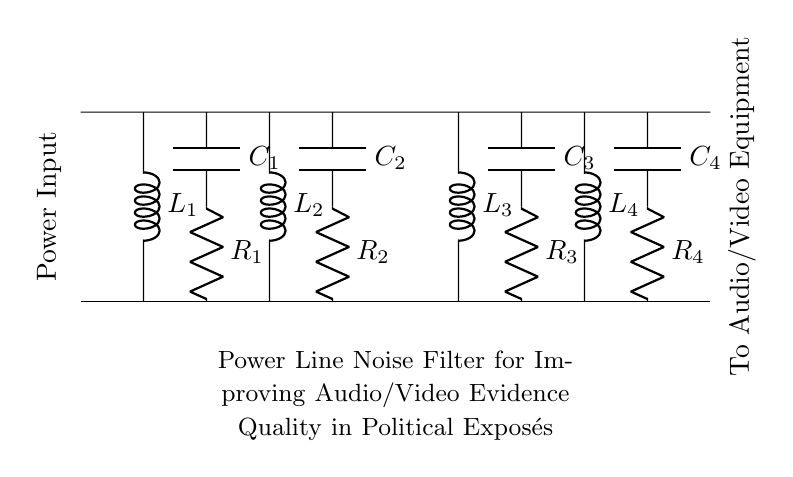What is the total number of inductors in the circuit? There are four inductors labeled L1, L2, L3, and L4 in the circuit diagram, which can be counted visually.
Answer: Four What type of components are R1, R2, R3, and R4? R1, R2, R3, and R4 are resistors. They can be identified by the 'R' label in the circuit diagram.
Answer: Resistors What is the purpose of the capacitors in this filter circuit? The capacitors (C1, C2, C3, C4) help to block any DC component in the signal and allow AC signals to pass, thus smoothing out noise. This is typical for noise filtering applications.
Answer: Noise filtering How many capacitors are used in the circuit? The circuit contains four capacitors indicated by the labels C1, C2, C3, and C4, which can be observed in the diagram.
Answer: Four Which components are connected in series between the power input and the audio/video equipment? The components connecting the power input to the audio/video equipment are arranged in series: L1, C1, R1, followed by L2, then C2, R2, L3, and so forth, checking the connection lines confirms this arrangement.
Answer: L1, C1, R1, L2, C2, R2, L3, C3, R3, L4, C4, R4 What is the primary function of this circuit? The primary function of this circuit is to filter noise from power lines which enhances the quality of audio and video signals, evident from the title specified in the diagram.
Answer: Filter noise 